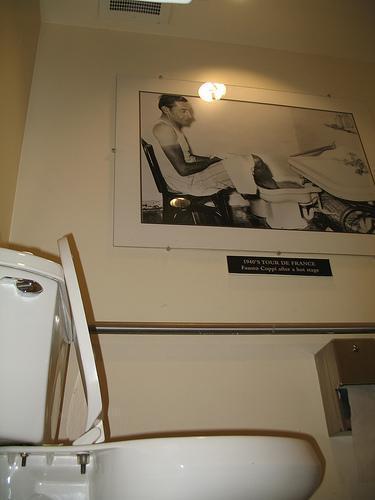How many toilets are there?
Give a very brief answer. 1. 